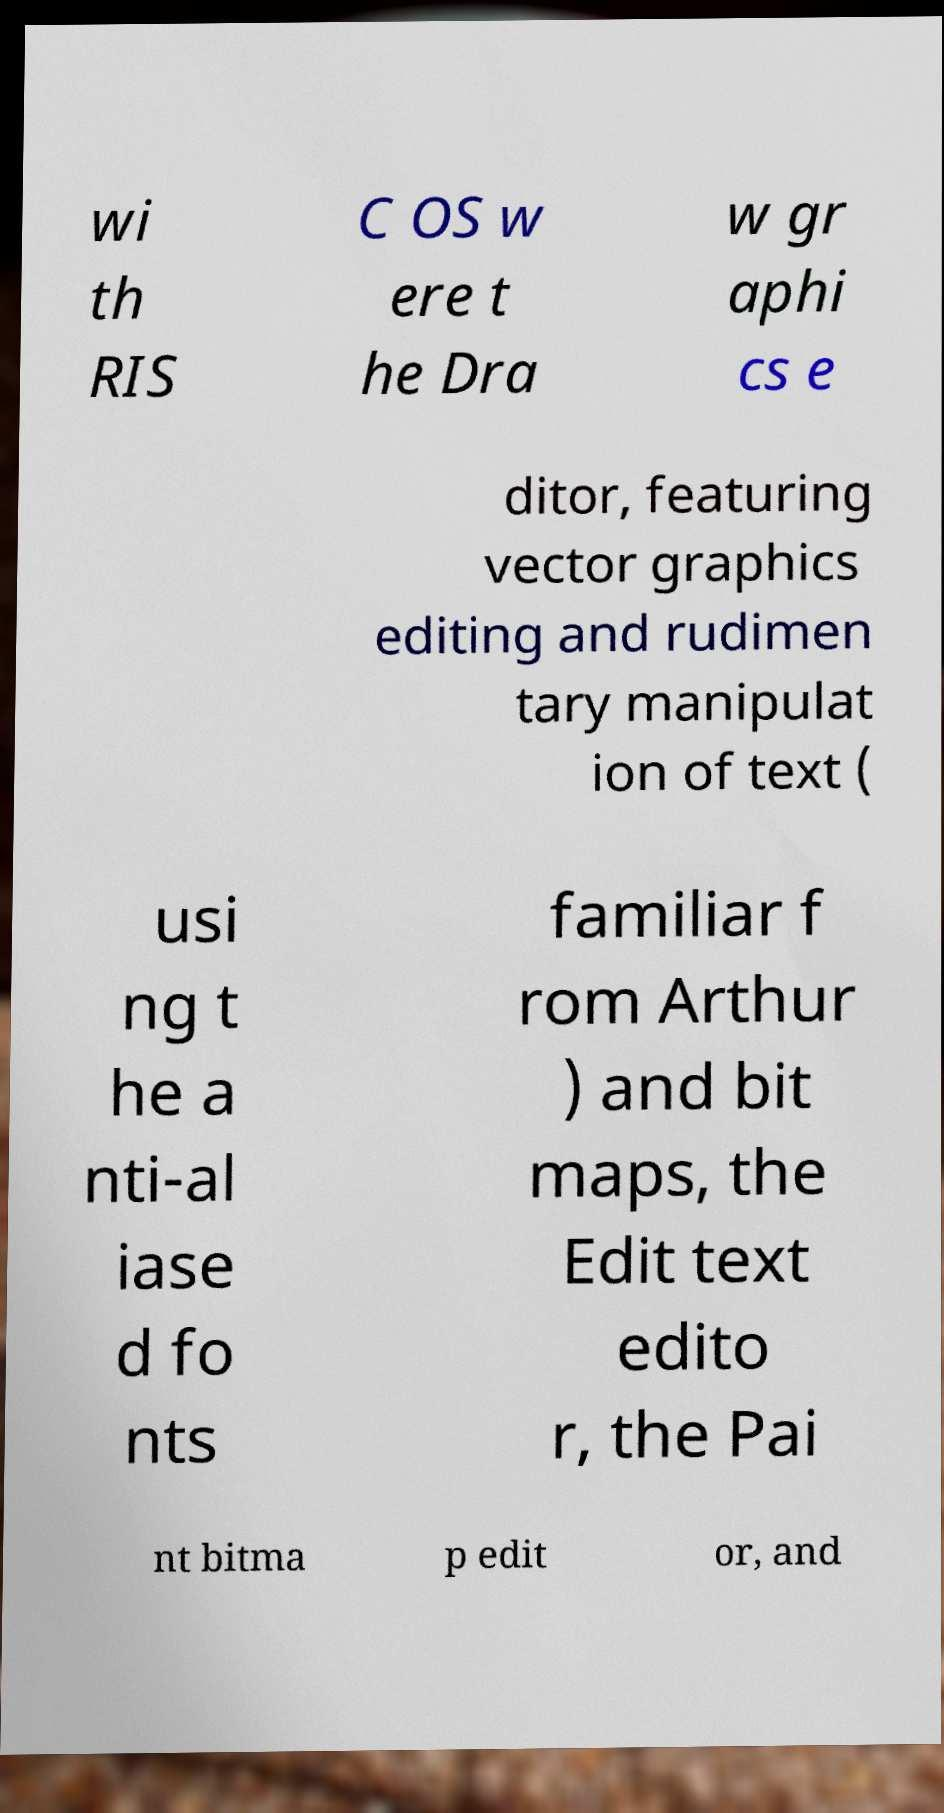For documentation purposes, I need the text within this image transcribed. Could you provide that? wi th RIS C OS w ere t he Dra w gr aphi cs e ditor, featuring vector graphics editing and rudimen tary manipulat ion of text ( usi ng t he a nti-al iase d fo nts familiar f rom Arthur ) and bit maps, the Edit text edito r, the Pai nt bitma p edit or, and 